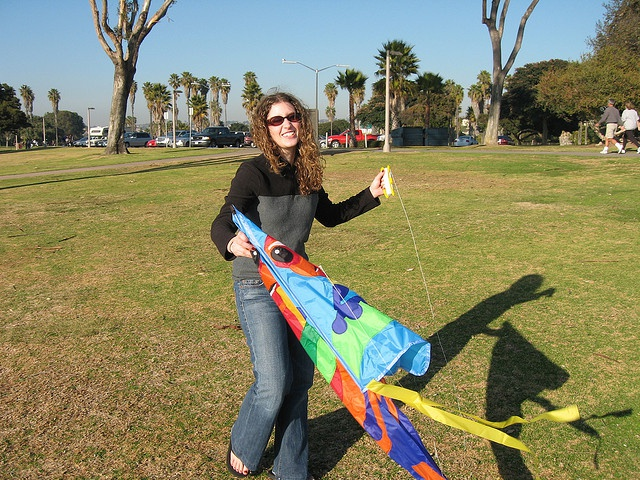Describe the objects in this image and their specific colors. I can see people in lightblue, black, gray, darkgray, and maroon tones, kite in lightblue, lightgreen, and khaki tones, truck in lightblue, black, gray, navy, and darkgray tones, people in lightblue, gray, tan, and ivory tones, and people in lightblue, lightgray, black, maroon, and darkgray tones in this image. 